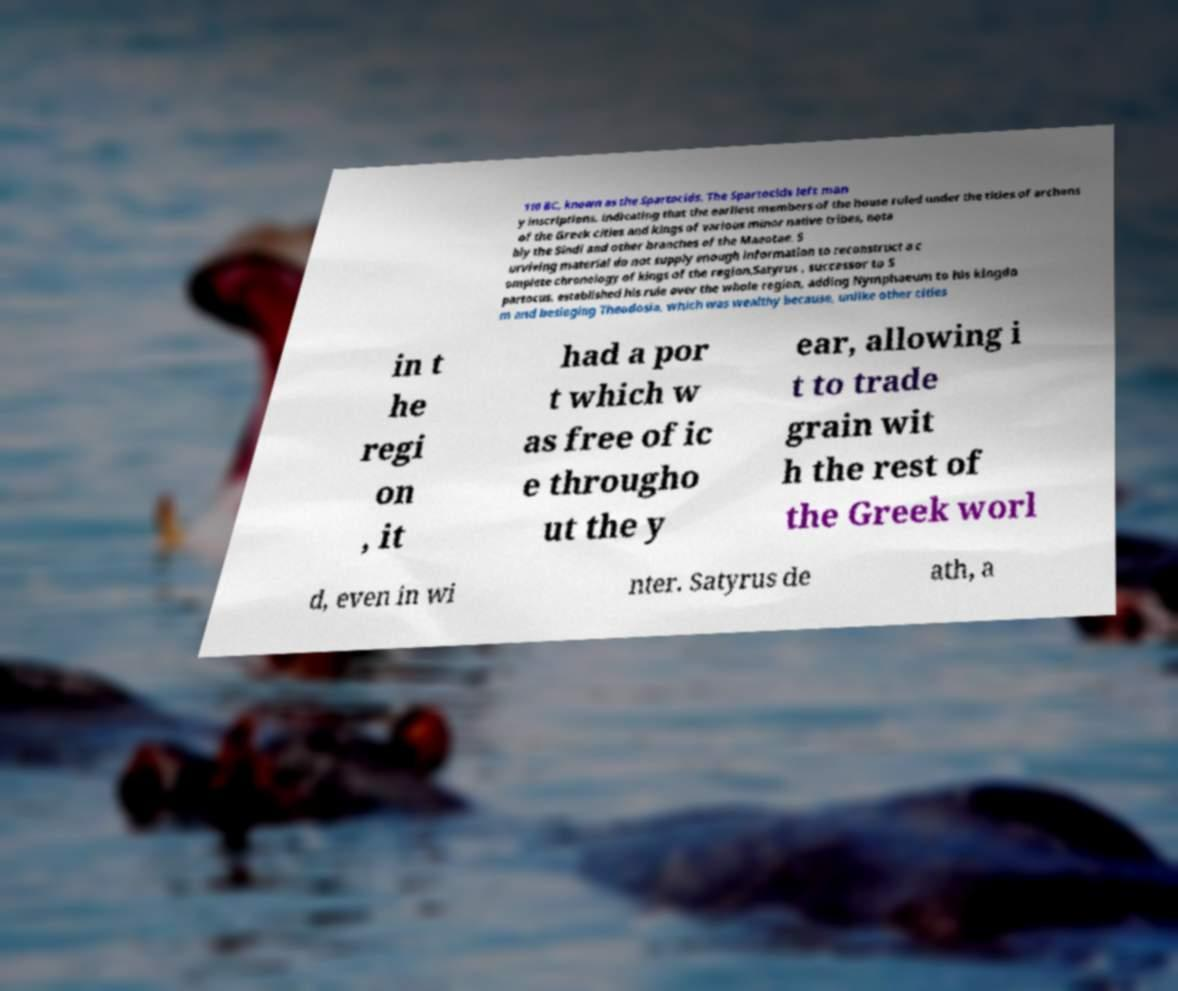There's text embedded in this image that I need extracted. Can you transcribe it verbatim? 110 BC, known as the Spartocids. The Spartocids left man y inscriptions, indicating that the earliest members of the house ruled under the titles of archons of the Greek cities and kings of various minor native tribes, nota bly the Sindi and other branches of the Maeotae. S urviving material do not supply enough information to reconstruct a c omplete chronology of kings of the region.Satyrus , successor to S partocus, established his rule over the whole region, adding Nymphaeum to his kingdo m and besieging Theodosia, which was wealthy because, unlike other cities in t he regi on , it had a por t which w as free of ic e througho ut the y ear, allowing i t to trade grain wit h the rest of the Greek worl d, even in wi nter. Satyrus de ath, a 